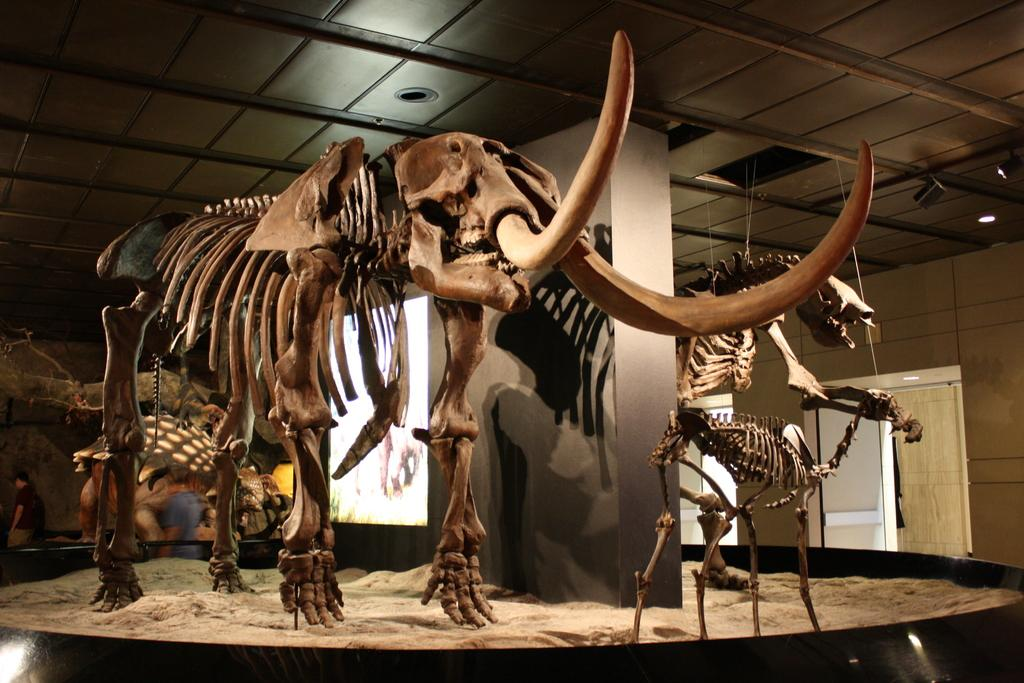What is the main subject of the picture? The main subject of the picture is a skeleton of an elephant. What can be seen on the floor in the picture? There is sand on the floor in the picture. What architectural features are visible in the backdrop of the picture? There is a pillar, a door, and a wall in the backdrop of the picture. How many tomatoes are on the wall in the picture? There are no tomatoes present in the picture; it features a skeleton of an elephant, sand on the floor, and architectural features in the backdrop. Can you describe the elephant jumping in the picture? There is no elephant jumping in the picture; it is a skeleton of an elephant, which cannot perform actions like jumping. 